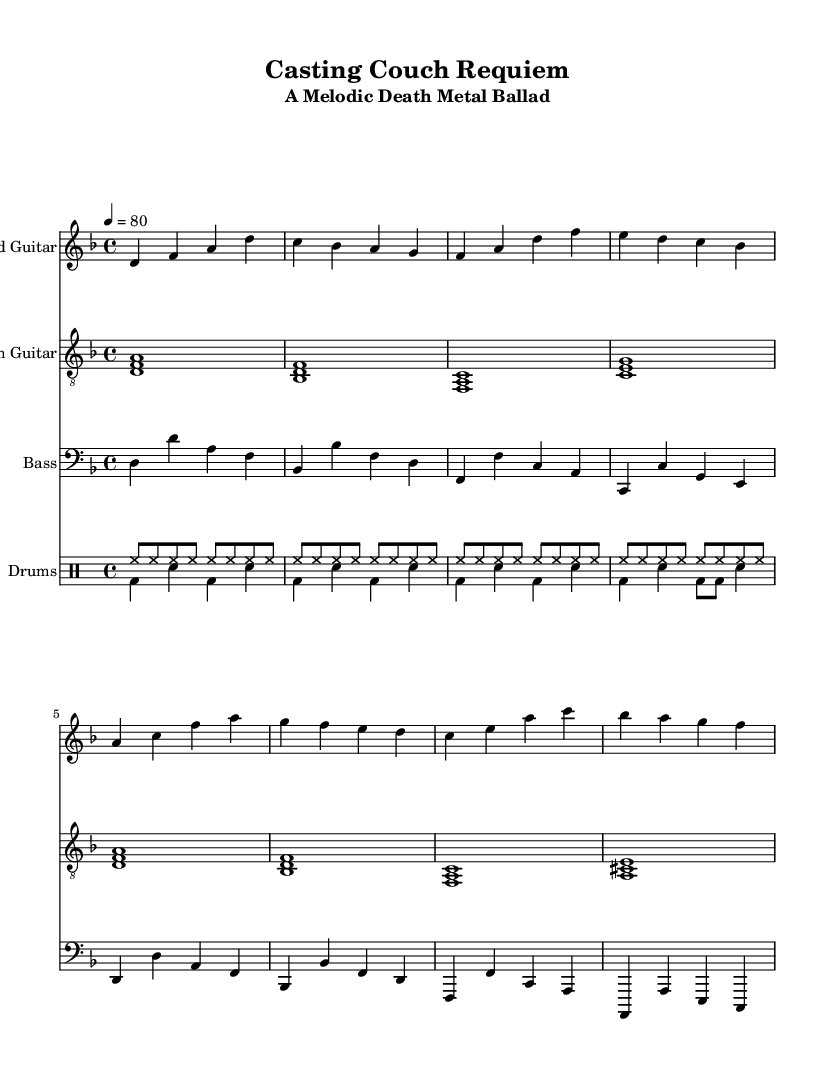What is the key signature of this music? The key signature is D minor, which has one flat (B♭). This can be identified by looking at the key signature clef at the beginning of the staff where it is specifically noted.
Answer: D minor What is the time signature of this music? The time signature is 4/4, indicated by the "4/4" written at the beginning of the score. This means there are four beats in each measure.
Answer: 4/4 What is the tempo of this piece? The tempo is marked as "4 = 80", which indicates that the quarter note (4) is equal to 80 beats per minute, describing the speed of the music.
Answer: 80 How many measures are there in the lead guitar part? Upon counting, the lead guitar part contains a total of 8 measures, as indicated by the number of vertical lines (bar lines) separating the music notes.
Answer: 8 What is the lead guitar's first note? The first note of the lead guitar part is D, found at the start of the line where the lead guitar notes begin. It is the very first note shown in the first measure.
Answer: D What is the dynamic level in the percussion section? The drum sheet does not specify dynamic markings, but it typically indicates a bright, energetic, and consistent level, which suggests a loud dynamic level common in metal music.
Answer: Loud Which instrument has the highest pitch in this piece? The lead guitar has the highest pitch, as it is situated in the treble clef, which typically denotes higher pitches than the bass guitar and drums found in lower clefs.
Answer: Lead Guitar 